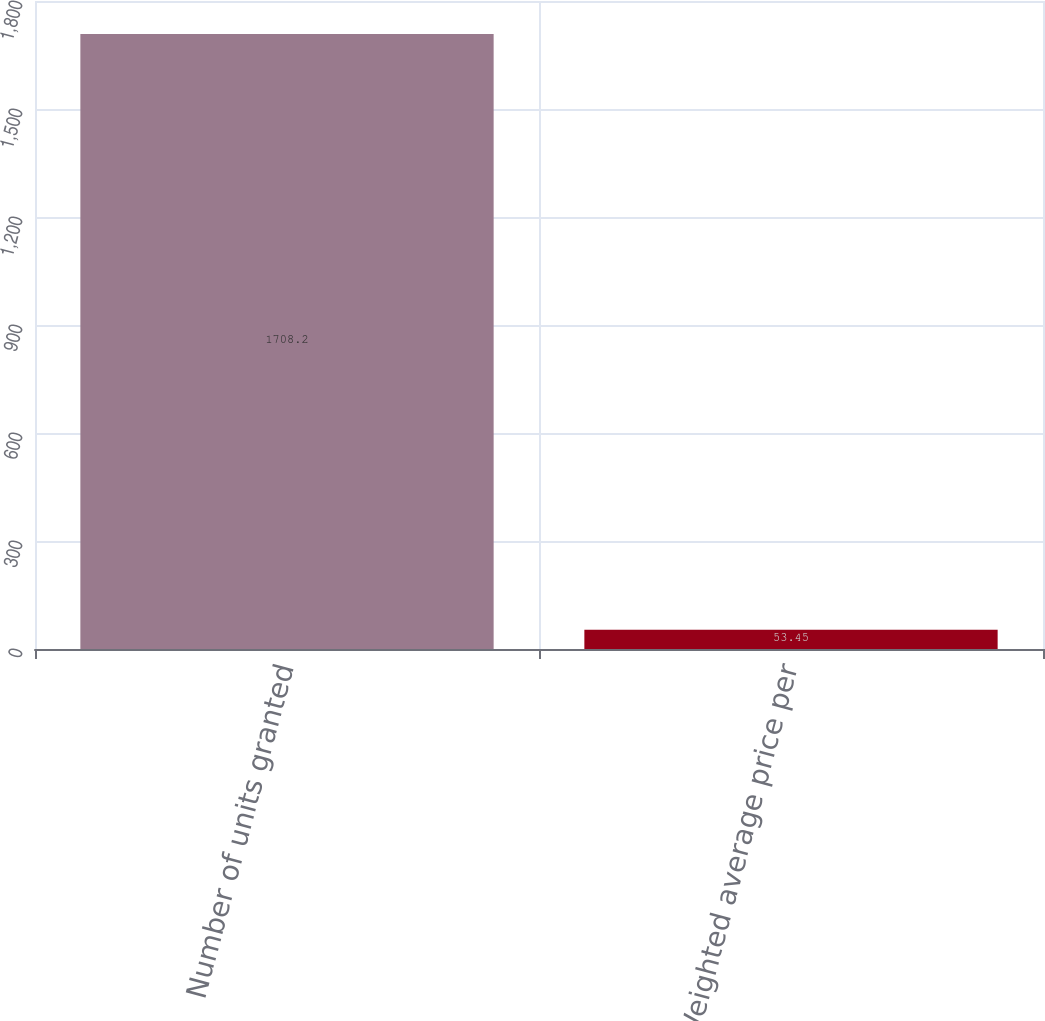Convert chart to OTSL. <chart><loc_0><loc_0><loc_500><loc_500><bar_chart><fcel>Number of units granted<fcel>Weighted average price per<nl><fcel>1708.2<fcel>53.45<nl></chart> 